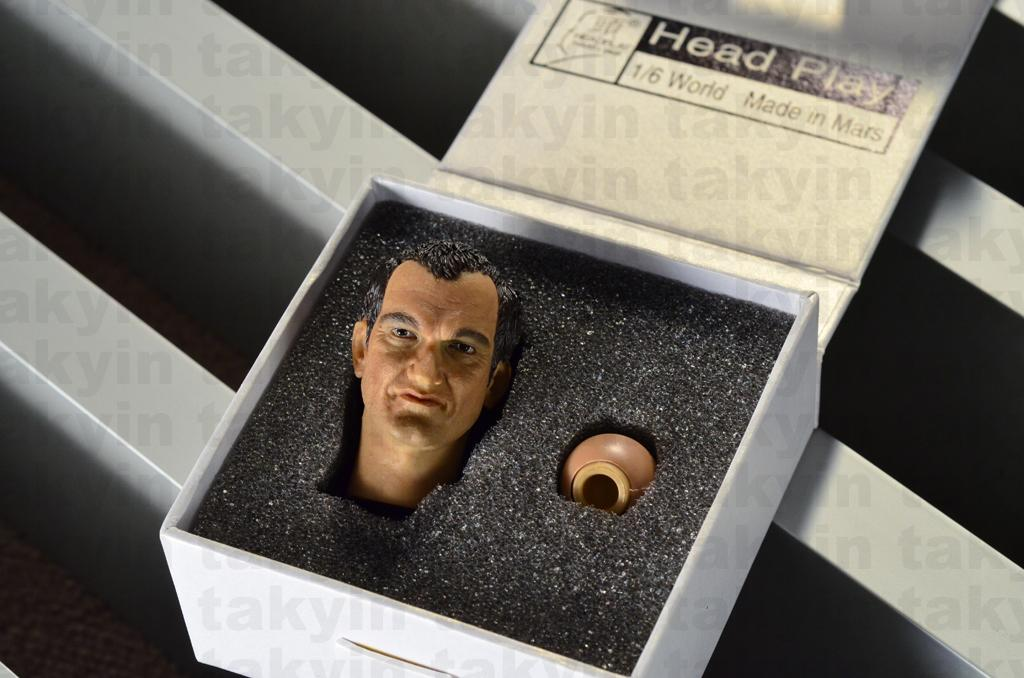What is the main subject of the image? The main subject of the image is a head sculpt. Where is the head sculpt located in the image? The head sculpt is inside a box. What type of coal is being used to fuel the fire in the image? There is no coal or fire present in the image; it features a head sculpt inside a box. How many bags can be seen in the image? There are no bags present in the image. 